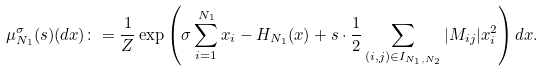Convert formula to latex. <formula><loc_0><loc_0><loc_500><loc_500>\mu _ { N _ { 1 } } ^ { \sigma } ( s ) ( d x ) \colon = \frac { 1 } { Z } \exp \left ( \sigma \sum _ { i = 1 } ^ { N _ { 1 } } x _ { i } - H _ { N _ { 1 } } ( x ) + s \cdot \frac { 1 } { 2 } \sum _ { ( i , j ) \in I _ { N _ { 1 } , N _ { 2 } } } | M _ { i j } | x _ { i } ^ { 2 } \right ) d x .</formula> 